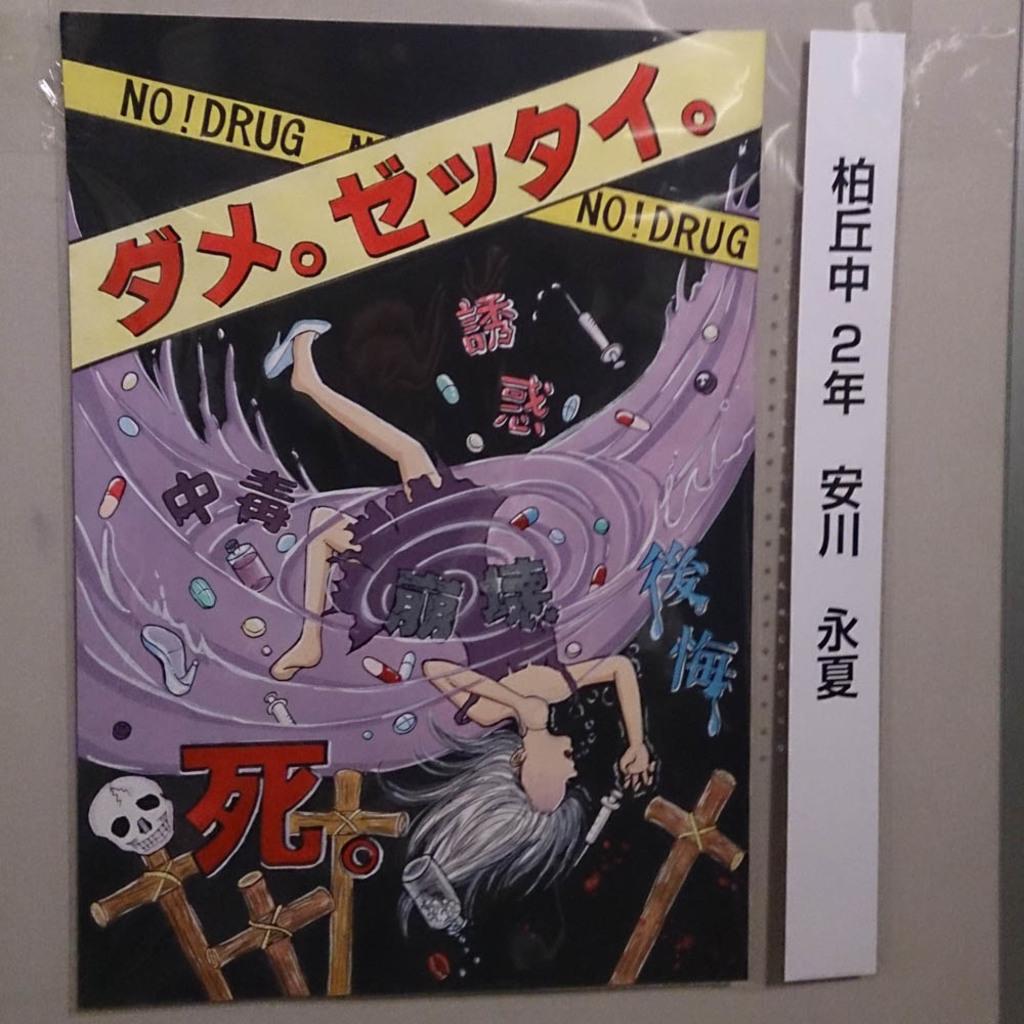What are they saying no to?
Ensure brevity in your answer.  Drug. 